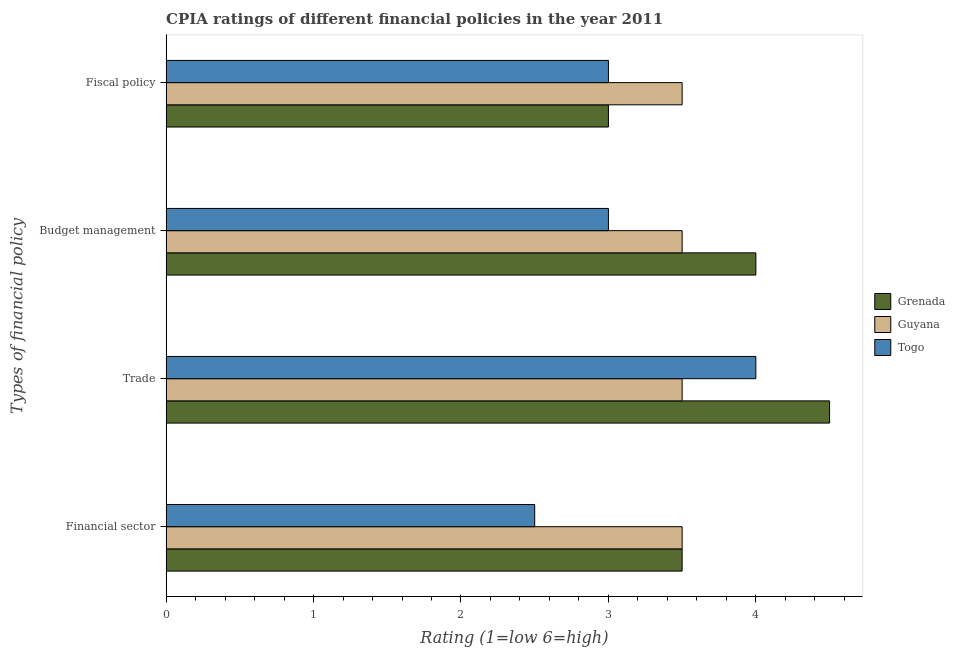How many groups of bars are there?
Provide a succinct answer. 4. Are the number of bars per tick equal to the number of legend labels?
Your answer should be compact. Yes. Are the number of bars on each tick of the Y-axis equal?
Offer a very short reply. Yes. What is the label of the 3rd group of bars from the top?
Offer a terse response. Trade. In which country was the cpia rating of fiscal policy maximum?
Provide a short and direct response. Guyana. In which country was the cpia rating of fiscal policy minimum?
Provide a succinct answer. Grenada. What is the average cpia rating of trade per country?
Give a very brief answer. 4. What is the difference between the cpia rating of financial sector and cpia rating of fiscal policy in Grenada?
Keep it short and to the point. 0.5. In how many countries, is the cpia rating of budget management greater than 3.8 ?
Provide a short and direct response. 1. What is the ratio of the cpia rating of budget management in Togo to that in Guyana?
Give a very brief answer. 0.86. What is the difference between the highest and the second highest cpia rating of fiscal policy?
Your answer should be very brief. 0.5. In how many countries, is the cpia rating of fiscal policy greater than the average cpia rating of fiscal policy taken over all countries?
Your answer should be compact. 1. What does the 3rd bar from the top in Fiscal policy represents?
Ensure brevity in your answer.  Grenada. What does the 2nd bar from the bottom in Budget management represents?
Offer a very short reply. Guyana. Are all the bars in the graph horizontal?
Ensure brevity in your answer.  Yes. How many countries are there in the graph?
Your answer should be compact. 3. Does the graph contain any zero values?
Your answer should be very brief. No. How many legend labels are there?
Your answer should be compact. 3. How are the legend labels stacked?
Give a very brief answer. Vertical. What is the title of the graph?
Provide a succinct answer. CPIA ratings of different financial policies in the year 2011. What is the label or title of the X-axis?
Ensure brevity in your answer.  Rating (1=low 6=high). What is the label or title of the Y-axis?
Your answer should be compact. Types of financial policy. What is the Rating (1=low 6=high) of Guyana in Financial sector?
Provide a succinct answer. 3.5. What is the Rating (1=low 6=high) of Grenada in Trade?
Ensure brevity in your answer.  4.5. What is the Rating (1=low 6=high) in Togo in Trade?
Offer a terse response. 4. What is the Rating (1=low 6=high) in Guyana in Budget management?
Give a very brief answer. 3.5. What is the Rating (1=low 6=high) in Togo in Budget management?
Keep it short and to the point. 3. What is the Rating (1=low 6=high) in Grenada in Fiscal policy?
Your answer should be very brief. 3. What is the Rating (1=low 6=high) in Guyana in Fiscal policy?
Ensure brevity in your answer.  3.5. What is the Rating (1=low 6=high) in Togo in Fiscal policy?
Give a very brief answer. 3. Across all Types of financial policy, what is the maximum Rating (1=low 6=high) of Guyana?
Your answer should be very brief. 3.5. Across all Types of financial policy, what is the maximum Rating (1=low 6=high) of Togo?
Offer a terse response. 4. Across all Types of financial policy, what is the minimum Rating (1=low 6=high) in Grenada?
Make the answer very short. 3. What is the total Rating (1=low 6=high) of Grenada in the graph?
Offer a terse response. 15. What is the total Rating (1=low 6=high) in Guyana in the graph?
Make the answer very short. 14. What is the difference between the Rating (1=low 6=high) of Grenada in Financial sector and that in Trade?
Offer a very short reply. -1. What is the difference between the Rating (1=low 6=high) in Guyana in Financial sector and that in Trade?
Provide a short and direct response. 0. What is the difference between the Rating (1=low 6=high) of Togo in Financial sector and that in Trade?
Your answer should be compact. -1.5. What is the difference between the Rating (1=low 6=high) of Guyana in Financial sector and that in Budget management?
Your answer should be compact. 0. What is the difference between the Rating (1=low 6=high) in Togo in Financial sector and that in Budget management?
Give a very brief answer. -0.5. What is the difference between the Rating (1=low 6=high) of Grenada in Financial sector and that in Fiscal policy?
Offer a very short reply. 0.5. What is the difference between the Rating (1=low 6=high) of Grenada in Trade and that in Budget management?
Provide a short and direct response. 0.5. What is the difference between the Rating (1=low 6=high) in Togo in Trade and that in Budget management?
Your answer should be compact. 1. What is the difference between the Rating (1=low 6=high) in Grenada in Trade and that in Fiscal policy?
Your response must be concise. 1.5. What is the difference between the Rating (1=low 6=high) in Guyana in Trade and that in Fiscal policy?
Provide a succinct answer. 0. What is the difference between the Rating (1=low 6=high) in Guyana in Budget management and that in Fiscal policy?
Offer a terse response. 0. What is the difference between the Rating (1=low 6=high) of Togo in Budget management and that in Fiscal policy?
Your answer should be compact. 0. What is the difference between the Rating (1=low 6=high) of Grenada in Financial sector and the Rating (1=low 6=high) of Guyana in Trade?
Your response must be concise. 0. What is the difference between the Rating (1=low 6=high) in Grenada in Financial sector and the Rating (1=low 6=high) in Togo in Trade?
Your response must be concise. -0.5. What is the difference between the Rating (1=low 6=high) in Guyana in Financial sector and the Rating (1=low 6=high) in Togo in Fiscal policy?
Offer a very short reply. 0.5. What is the difference between the Rating (1=low 6=high) in Grenada in Trade and the Rating (1=low 6=high) in Togo in Budget management?
Give a very brief answer. 1.5. What is the difference between the Rating (1=low 6=high) of Guyana in Trade and the Rating (1=low 6=high) of Togo in Budget management?
Your answer should be very brief. 0.5. What is the difference between the Rating (1=low 6=high) of Grenada in Trade and the Rating (1=low 6=high) of Guyana in Fiscal policy?
Make the answer very short. 1. What is the difference between the Rating (1=low 6=high) in Grenada in Budget management and the Rating (1=low 6=high) in Togo in Fiscal policy?
Ensure brevity in your answer.  1. What is the average Rating (1=low 6=high) of Grenada per Types of financial policy?
Provide a short and direct response. 3.75. What is the average Rating (1=low 6=high) in Guyana per Types of financial policy?
Your answer should be compact. 3.5. What is the average Rating (1=low 6=high) in Togo per Types of financial policy?
Give a very brief answer. 3.12. What is the difference between the Rating (1=low 6=high) in Grenada and Rating (1=low 6=high) in Guyana in Financial sector?
Ensure brevity in your answer.  0. What is the difference between the Rating (1=low 6=high) in Grenada and Rating (1=low 6=high) in Togo in Financial sector?
Your answer should be compact. 1. What is the difference between the Rating (1=low 6=high) of Grenada and Rating (1=low 6=high) of Guyana in Trade?
Offer a very short reply. 1. What is the difference between the Rating (1=low 6=high) in Grenada and Rating (1=low 6=high) in Togo in Trade?
Provide a succinct answer. 0.5. What is the difference between the Rating (1=low 6=high) of Guyana and Rating (1=low 6=high) of Togo in Trade?
Keep it short and to the point. -0.5. What is the difference between the Rating (1=low 6=high) in Guyana and Rating (1=low 6=high) in Togo in Budget management?
Ensure brevity in your answer.  0.5. What is the difference between the Rating (1=low 6=high) of Grenada and Rating (1=low 6=high) of Guyana in Fiscal policy?
Offer a very short reply. -0.5. What is the difference between the Rating (1=low 6=high) in Guyana and Rating (1=low 6=high) in Togo in Fiscal policy?
Give a very brief answer. 0.5. What is the ratio of the Rating (1=low 6=high) in Grenada in Financial sector to that in Trade?
Your answer should be compact. 0.78. What is the ratio of the Rating (1=low 6=high) of Guyana in Financial sector to that in Trade?
Your answer should be compact. 1. What is the ratio of the Rating (1=low 6=high) of Grenada in Financial sector to that in Budget management?
Your answer should be very brief. 0.88. What is the ratio of the Rating (1=low 6=high) in Togo in Financial sector to that in Fiscal policy?
Give a very brief answer. 0.83. What is the ratio of the Rating (1=low 6=high) of Guyana in Trade to that in Budget management?
Your answer should be compact. 1. What is the ratio of the Rating (1=low 6=high) in Guyana in Trade to that in Fiscal policy?
Ensure brevity in your answer.  1. What is the ratio of the Rating (1=low 6=high) of Togo in Trade to that in Fiscal policy?
Offer a terse response. 1.33. What is the ratio of the Rating (1=low 6=high) of Grenada in Budget management to that in Fiscal policy?
Keep it short and to the point. 1.33. What is the ratio of the Rating (1=low 6=high) of Guyana in Budget management to that in Fiscal policy?
Give a very brief answer. 1. What is the ratio of the Rating (1=low 6=high) in Togo in Budget management to that in Fiscal policy?
Your answer should be compact. 1. What is the difference between the highest and the second highest Rating (1=low 6=high) in Guyana?
Provide a succinct answer. 0. What is the difference between the highest and the second highest Rating (1=low 6=high) of Togo?
Offer a terse response. 1. What is the difference between the highest and the lowest Rating (1=low 6=high) of Grenada?
Keep it short and to the point. 1.5. 